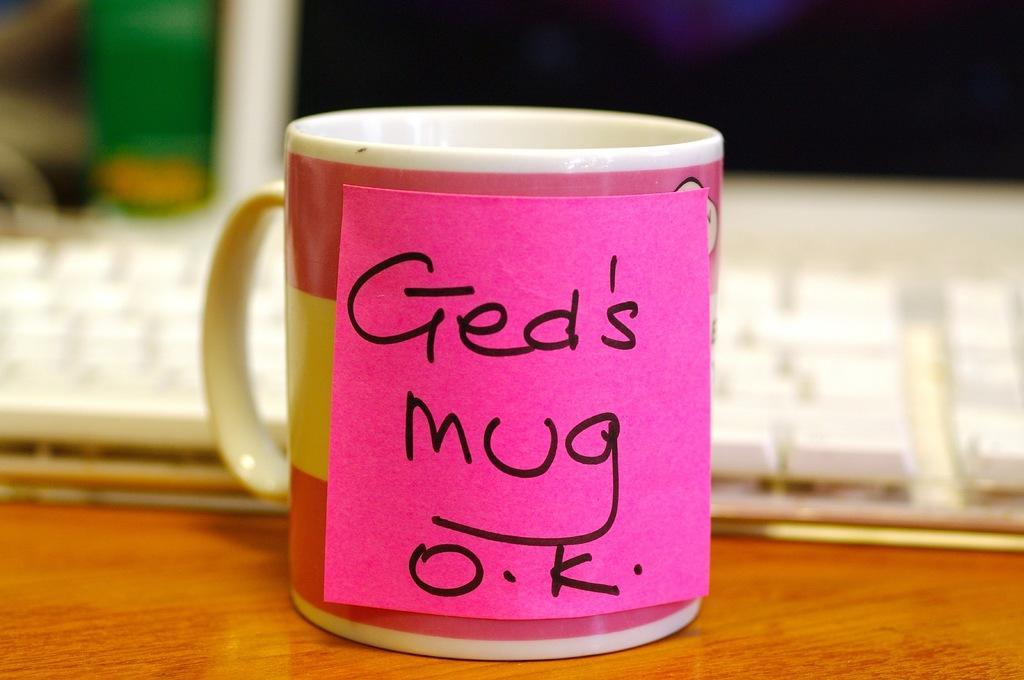<image>
Describe the image concisely. A pink and yellow mug in front of a key board has a pink post it note letting everyone know it's Ged's. 